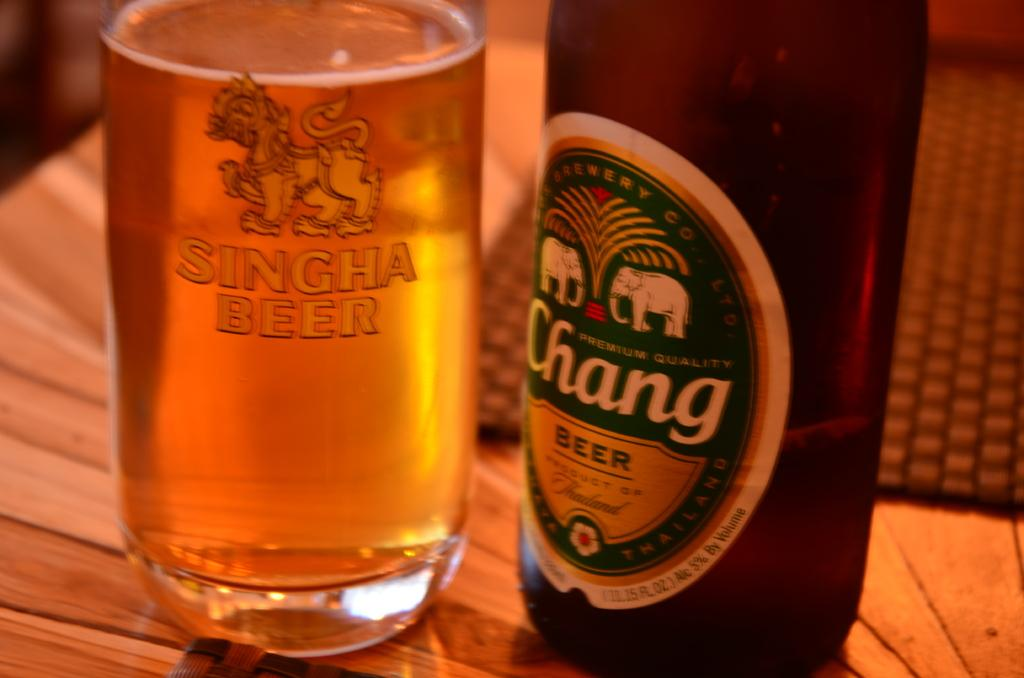<image>
Render a clear and concise summary of the photo. A glass of beer has the words SINGHA BEER imprinted on it. 